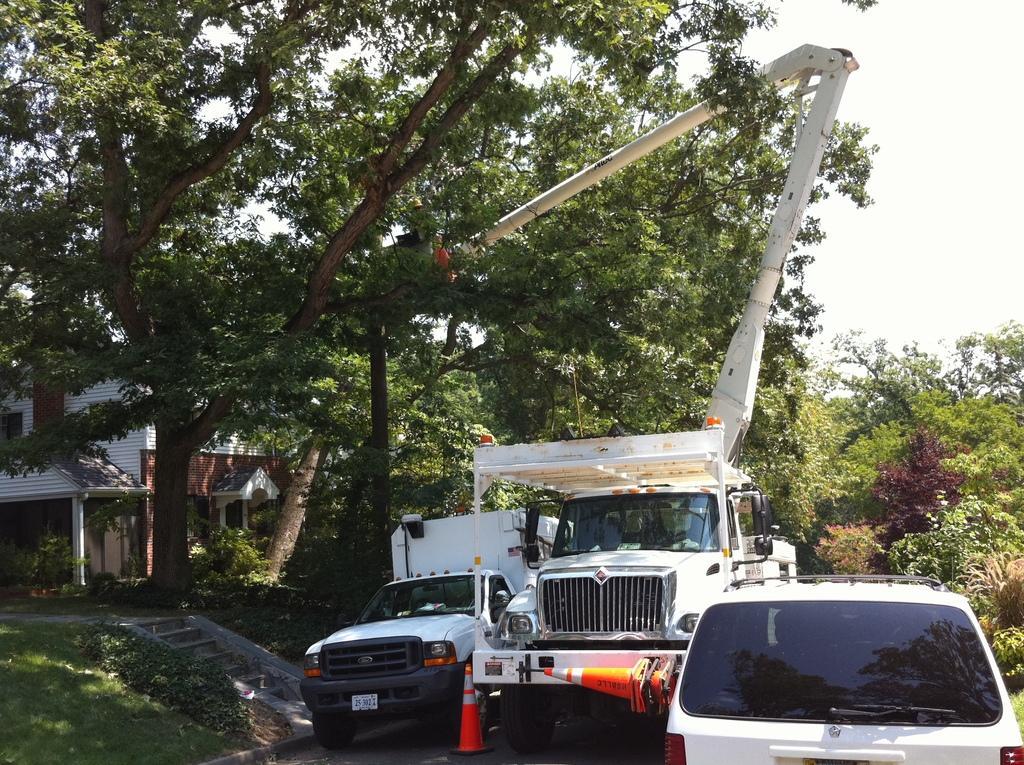How would you summarize this image in a sentence or two? In this image I can see few white colour vehicles, few orange colored traffic cones, grass, stairs, a building and number of trees. 